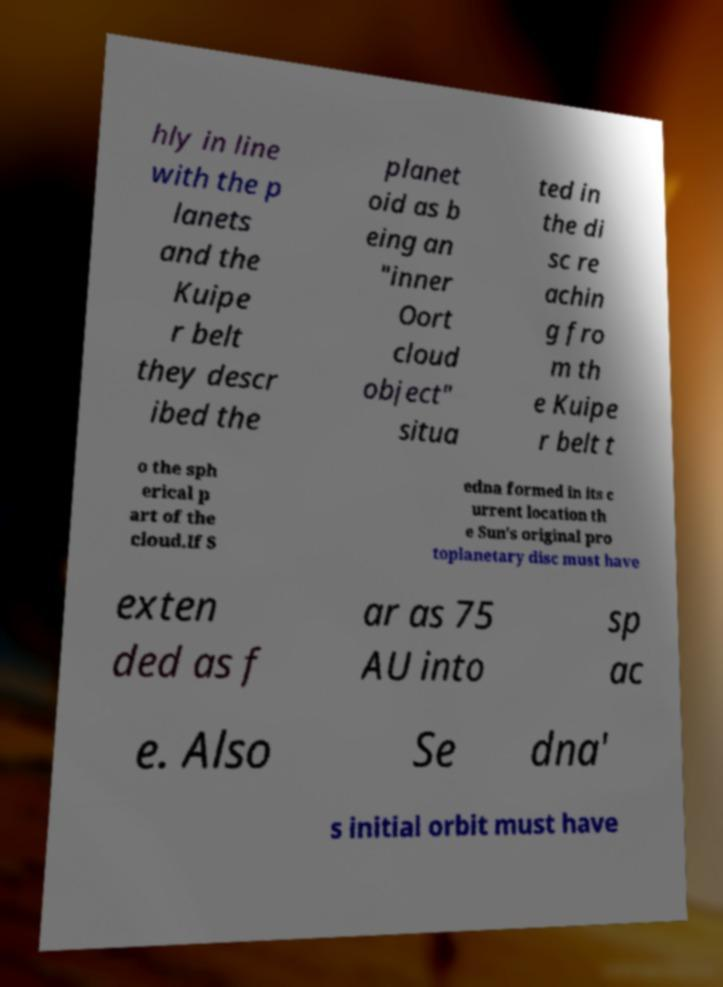What messages or text are displayed in this image? I need them in a readable, typed format. hly in line with the p lanets and the Kuipe r belt they descr ibed the planet oid as b eing an "inner Oort cloud object" situa ted in the di sc re achin g fro m th e Kuipe r belt t o the sph erical p art of the cloud.If S edna formed in its c urrent location th e Sun's original pro toplanetary disc must have exten ded as f ar as 75 AU into sp ac e. Also Se dna' s initial orbit must have 